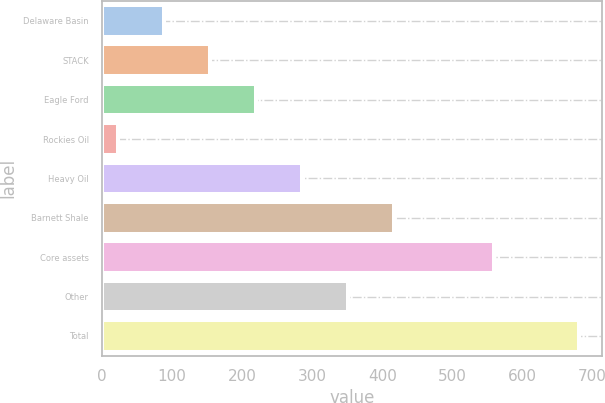Convert chart. <chart><loc_0><loc_0><loc_500><loc_500><bar_chart><fcel>Delaware Basin<fcel>STACK<fcel>Eagle Ford<fcel>Rockies Oil<fcel>Heavy Oil<fcel>Barnett Shale<fcel>Core assets<fcel>Other<fcel>Total<nl><fcel>88.7<fcel>154.4<fcel>220.1<fcel>23<fcel>285.8<fcel>417.2<fcel>560<fcel>351.5<fcel>680<nl></chart> 